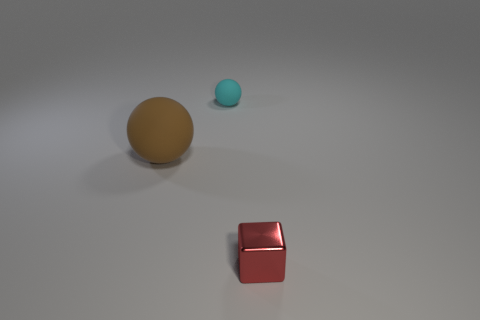Add 2 blue metal things. How many objects exist? 5 Subtract all blocks. How many objects are left? 2 Subtract all rubber spheres. Subtract all small red blocks. How many objects are left? 0 Add 3 large brown spheres. How many large brown spheres are left? 4 Add 1 big brown things. How many big brown things exist? 2 Subtract 0 purple cylinders. How many objects are left? 3 